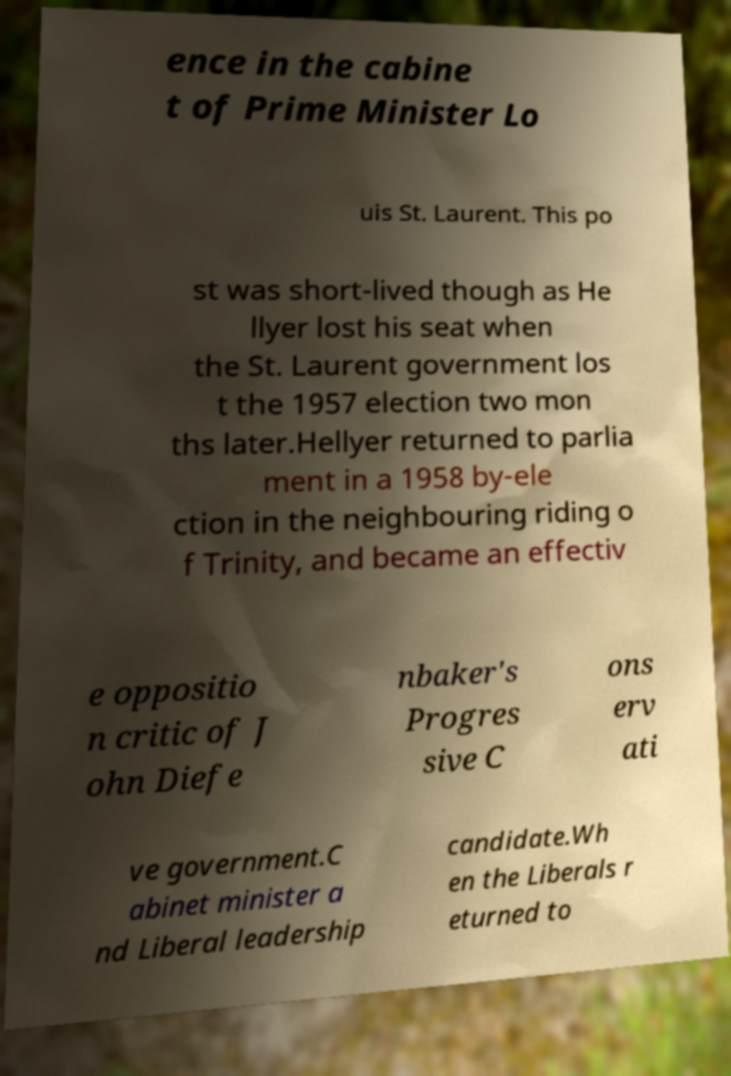Can you accurately transcribe the text from the provided image for me? ence in the cabine t of Prime Minister Lo uis St. Laurent. This po st was short-lived though as He llyer lost his seat when the St. Laurent government los t the 1957 election two mon ths later.Hellyer returned to parlia ment in a 1958 by-ele ction in the neighbouring riding o f Trinity, and became an effectiv e oppositio n critic of J ohn Diefe nbaker's Progres sive C ons erv ati ve government.C abinet minister a nd Liberal leadership candidate.Wh en the Liberals r eturned to 